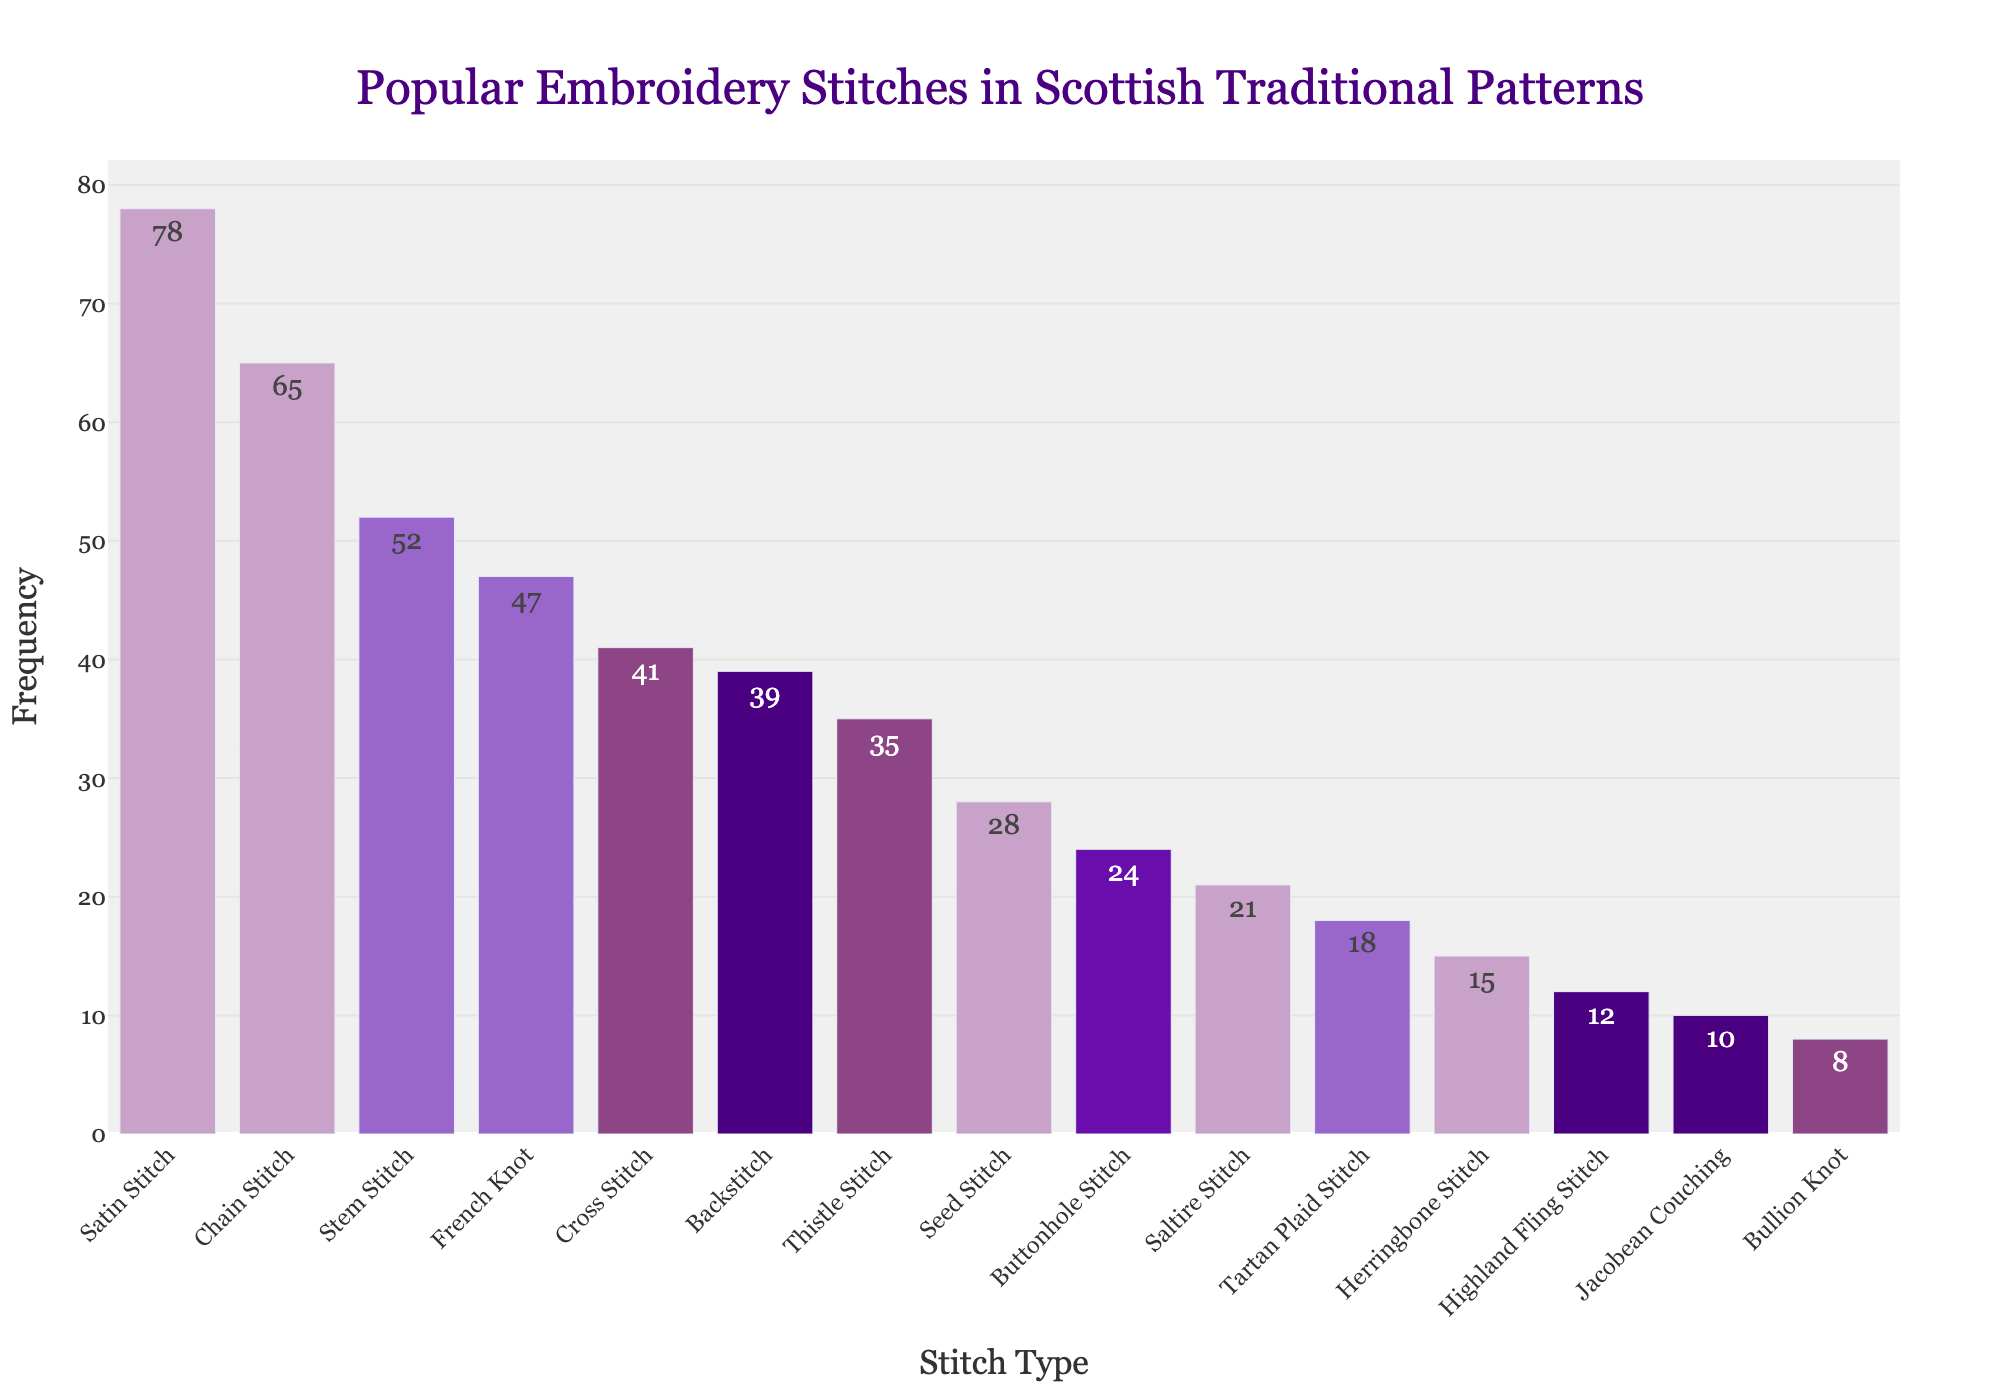Which stitch type is the most popular in Scottish traditional patterns? The height of the bar represents the frequency. The highest bar corresponds to the 'Satin Stitch', indicating it is the most popular.
Answer: Satin Stitch Which stitches have a frequency greater than 50? Identifying all bars with heights above the 50 mark reveals the stitches: 'Satin Stitch', 'Chain Stitch', and 'Stem Stitch'.
Answer: Satin Stitch, Chain Stitch, Stem Stitch What is the difference in frequency between the most and least popular stitches? The most popular stitch (Satin Stitch) has a frequency of 78, while the least popular stitch (Bullion Knot) has a frequency of 8. The difference is calculated as 78 - 8 = 70.
Answer: 70 Which stitch types have a frequency below 20? By examining the bars, the stitch types 'Tartan Plaid Stitch', 'Herringbone Stitch', 'Highland Fling Stitch', 'Jacobean Couching', and 'Bullion Knot' have frequencies below 20.
Answer: Tartan Plaid Stitch, Herringbone Stitch, Highland Fling Stitch, Jacobean Couching, Bullion Knot What is the combined frequency of 'Chain Stitch', 'Stem Stitch', and 'French Knot'? Summing the frequencies: Chain Stitch (65) + Stem Stitch (52) + French Knot (47) gives us 164.
Answer: 164 Which stitch type has the second highest frequency and what is that frequency? The second highest bar corresponds to 'Chain Stitch', which has a frequency of 65.
Answer: Chain Stitch, 65 Are there more stitches with a frequency above or below 40? Count the stitches above 40: (Satin Stitch, Chain Stitch, Stem Stitch, French Knot) = 4. Count the stitches below 40: (Cross Stitch, Backstitch, Thistle Stitch, Seed Stitch, Buttonhole Stitch, Saltire Stitch, Tartan Plaid Stitch, Herringbone Stitch, Highland Fling Stitch, Jacobean Couching, Bullion Knot) = 11.
Answer: Below What is the average frequency of all the stitches? Adding the frequencies: 78 + 65 + 52 + 47 + 41 + 39 + 35 + 28 + 24 + 21 + 18 + 15 + 12 + 10 + 8 = 493. The number of stitches is 15, so the average is 493 / 15 ≈ 32.87.
Answer: 32.87 Is 'Backstitch' more or less popular than 'Cross Stitch' and by how much? The frequency for 'Backstitch' is 39, and for 'Cross Stitch' it is 41. The difference is 41 - 39 = 2, showing 'Backstitch' is less popular by 2.
Answer: Less, 2 Which stitches would be considered moderately popular with frequencies between 20 and 40? Reviewing the bars within the specified range, the stitches identified are: 'Cross Stitch', 'Backstitch', 'Thistle Stitch', 'Seed Stitch', and 'Buttonhole Stitch'.
Answer: Cross Stitch, Backstitch, Thistle Stitch, Seed Stitch, Buttonhole Stitch 